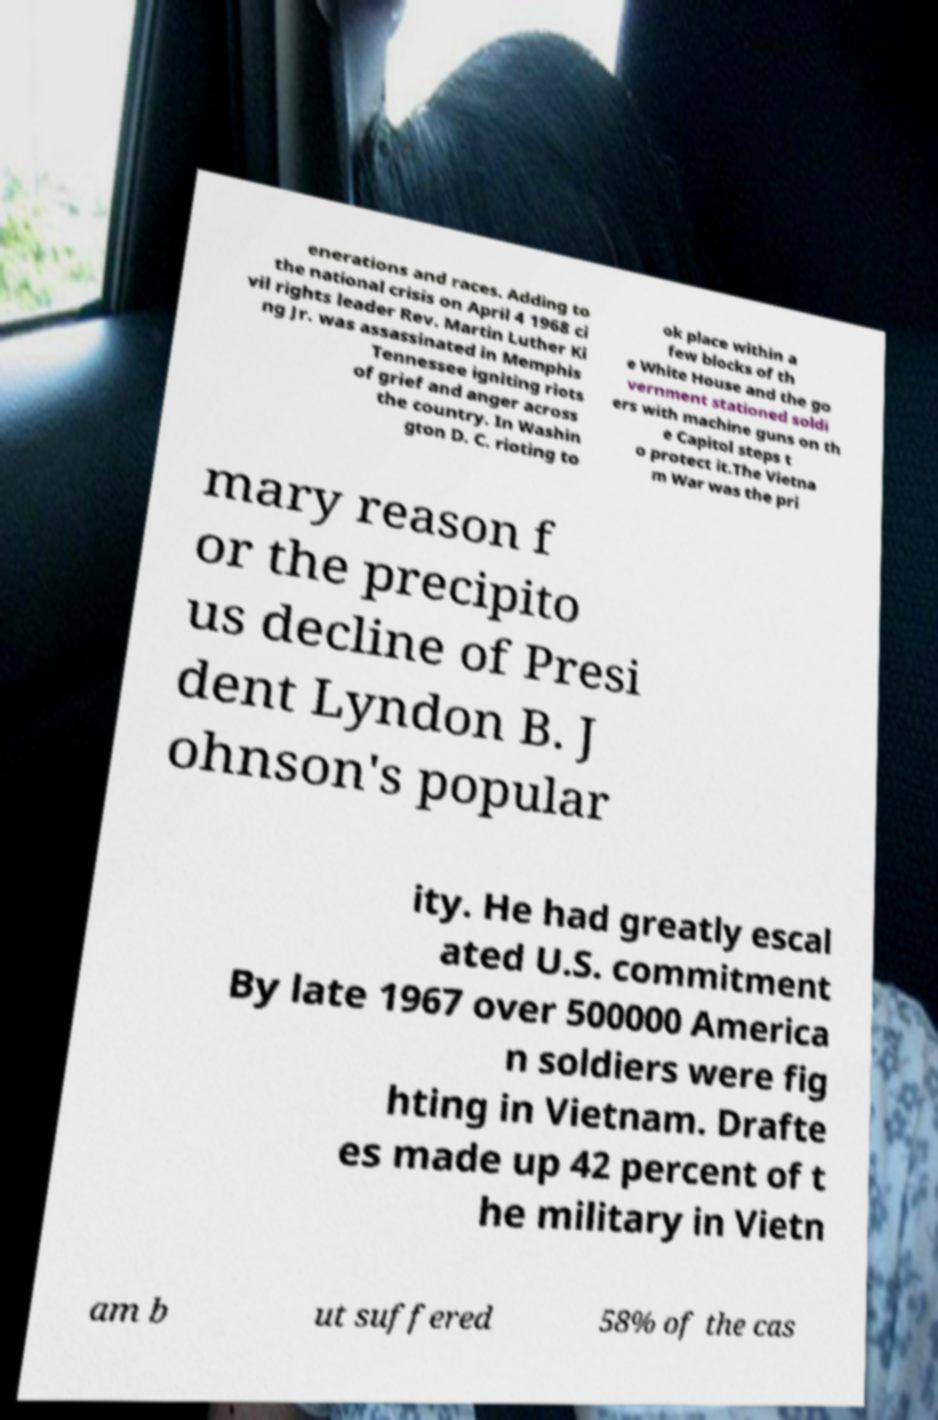What messages or text are displayed in this image? I need them in a readable, typed format. enerations and races. Adding to the national crisis on April 4 1968 ci vil rights leader Rev. Martin Luther Ki ng Jr. was assassinated in Memphis Tennessee igniting riots of grief and anger across the country. In Washin gton D. C. rioting to ok place within a few blocks of th e White House and the go vernment stationed soldi ers with machine guns on th e Capitol steps t o protect it.The Vietna m War was the pri mary reason f or the precipito us decline of Presi dent Lyndon B. J ohnson's popular ity. He had greatly escal ated U.S. commitment By late 1967 over 500000 America n soldiers were fig hting in Vietnam. Drafte es made up 42 percent of t he military in Vietn am b ut suffered 58% of the cas 